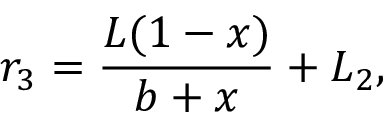<formula> <loc_0><loc_0><loc_500><loc_500>r _ { 3 } = \frac { L ( 1 - x ) } { b + x } + L _ { 2 } ,</formula> 